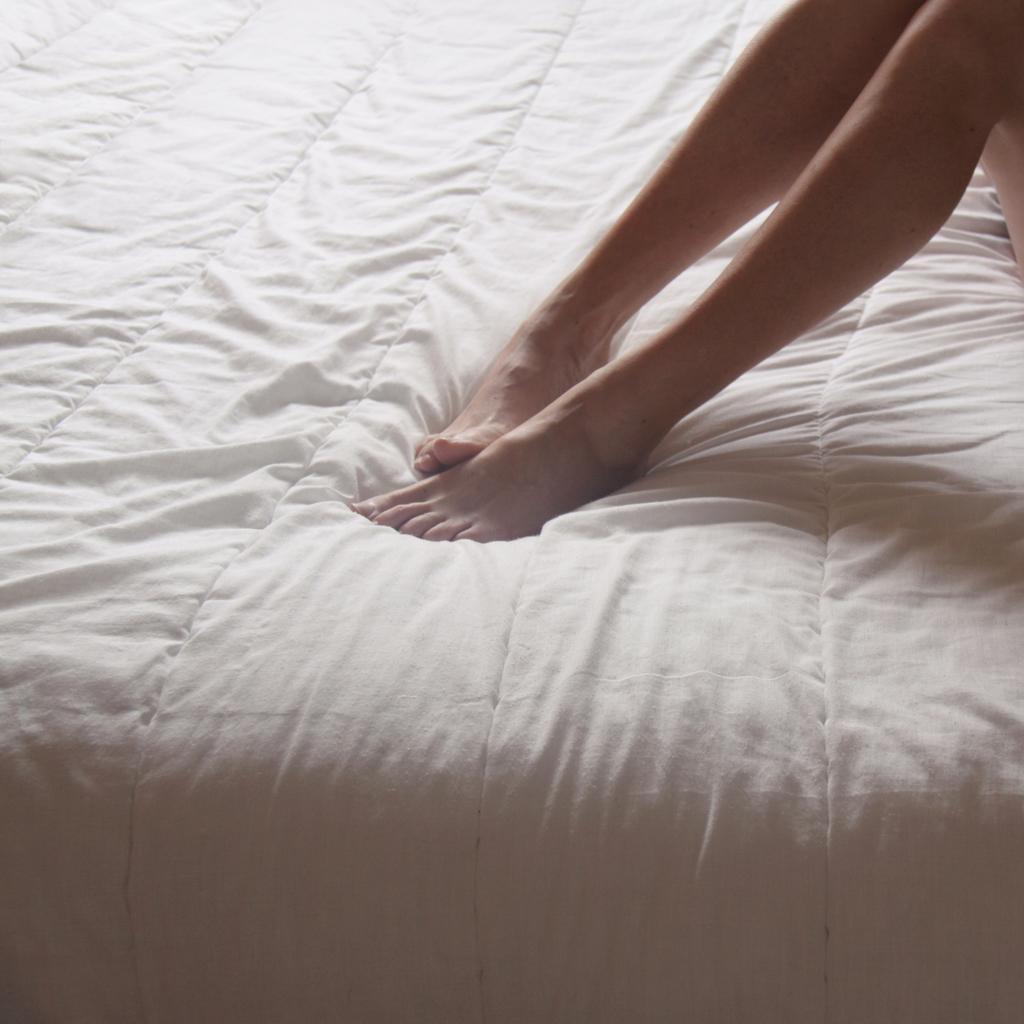Could you give a brief overview of what you see in this image? In this image there are person legs on the blanket of the bed. 